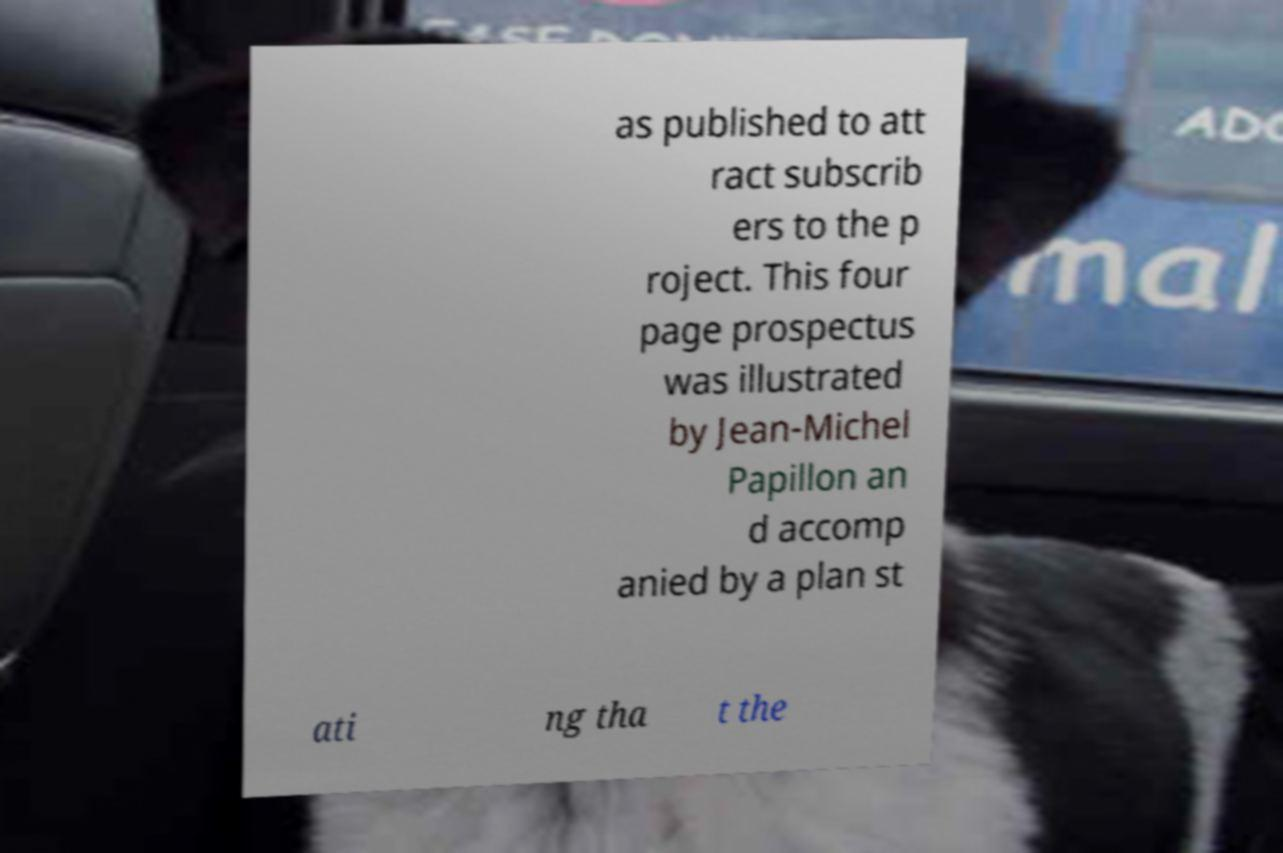Please identify and transcribe the text found in this image. as published to att ract subscrib ers to the p roject. This four page prospectus was illustrated by Jean-Michel Papillon an d accomp anied by a plan st ati ng tha t the 